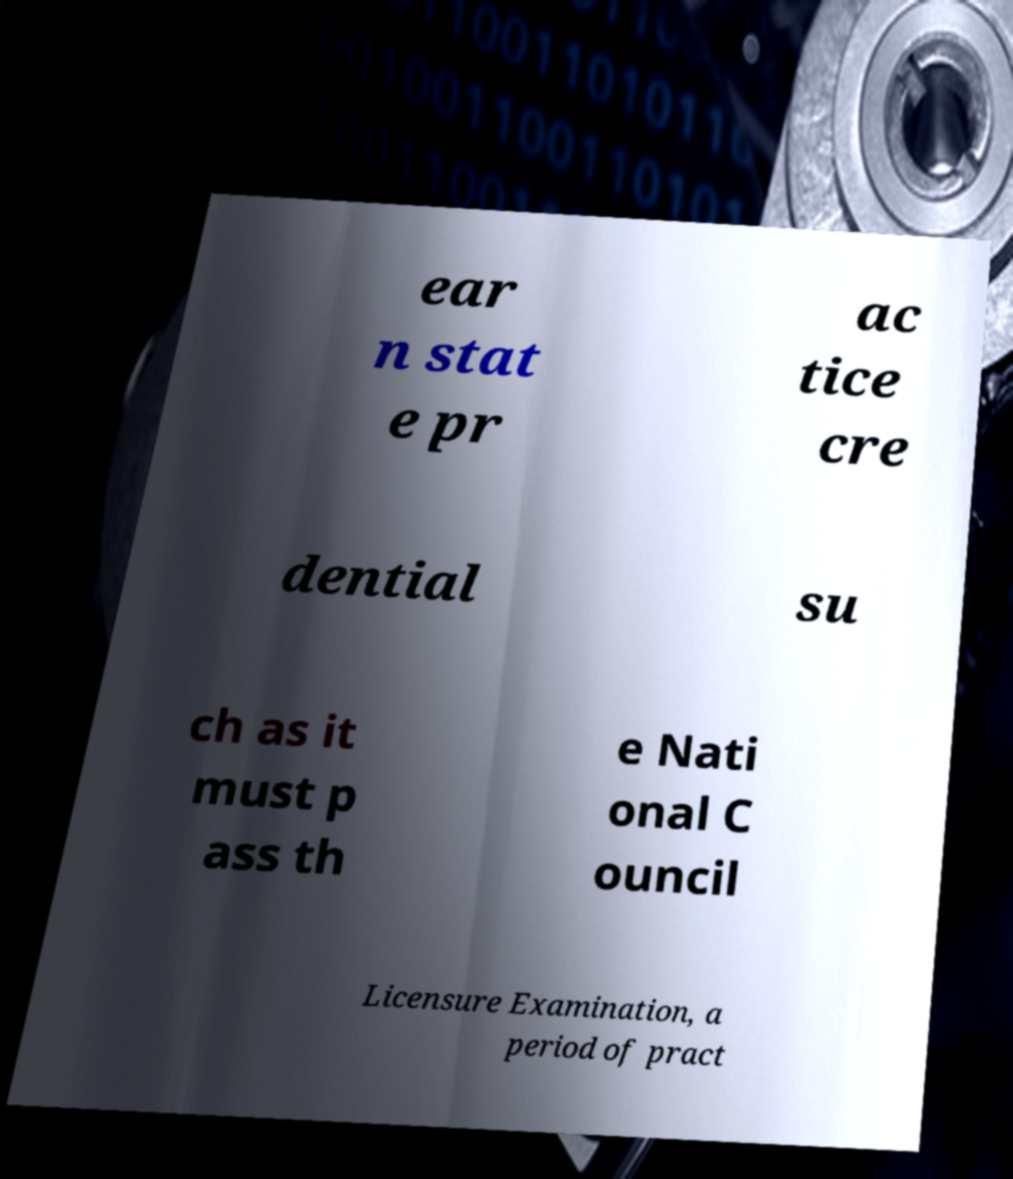Could you assist in decoding the text presented in this image and type it out clearly? ear n stat e pr ac tice cre dential su ch as it must p ass th e Nati onal C ouncil Licensure Examination, a period of pract 